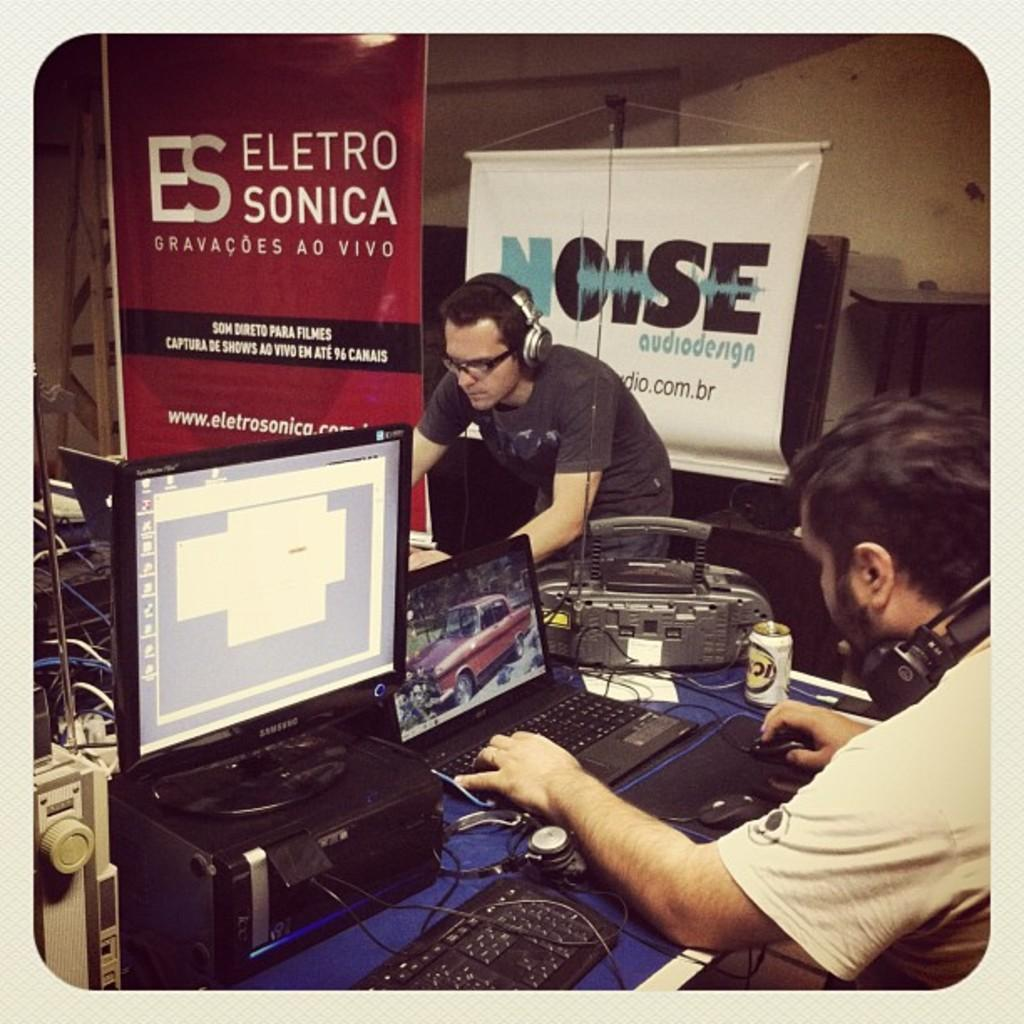<image>
Share a concise interpretation of the image provided. Some men are working with their laptop with a banner from Eletro Sonica in the background 